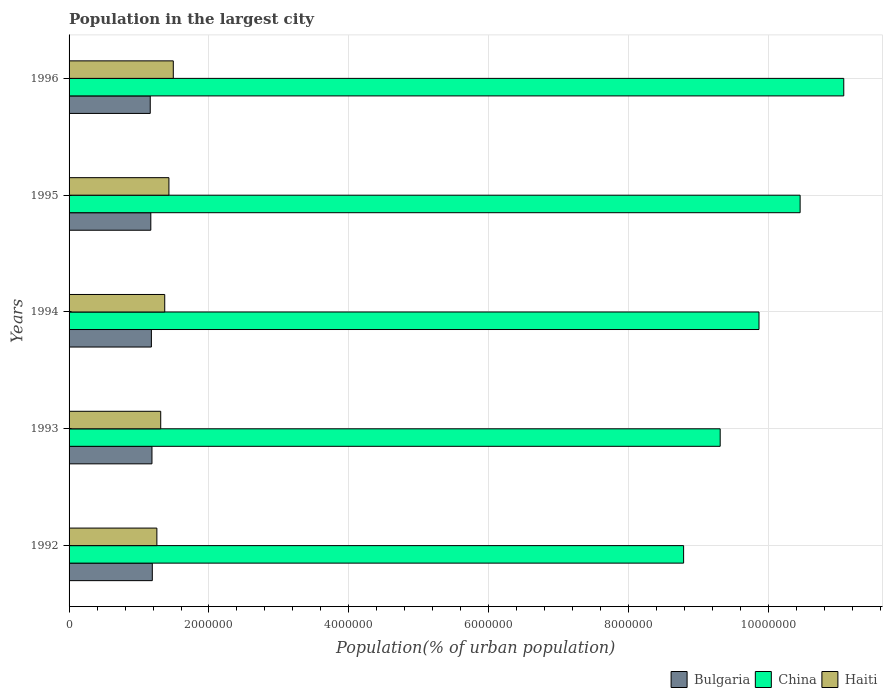How many different coloured bars are there?
Offer a very short reply. 3. How many groups of bars are there?
Give a very brief answer. 5. Are the number of bars on each tick of the Y-axis equal?
Keep it short and to the point. Yes. How many bars are there on the 3rd tick from the bottom?
Offer a very short reply. 3. In how many cases, is the number of bars for a given year not equal to the number of legend labels?
Ensure brevity in your answer.  0. What is the population in the largest city in China in 1992?
Offer a terse response. 8.78e+06. Across all years, what is the maximum population in the largest city in Bulgaria?
Your response must be concise. 1.19e+06. Across all years, what is the minimum population in the largest city in Bulgaria?
Give a very brief answer. 1.16e+06. In which year was the population in the largest city in Bulgaria maximum?
Offer a very short reply. 1992. What is the total population in the largest city in China in the graph?
Give a very brief answer. 4.95e+07. What is the difference between the population in the largest city in China in 1993 and that in 1994?
Offer a terse response. -5.55e+05. What is the difference between the population in the largest city in China in 1992 and the population in the largest city in Bulgaria in 1996?
Offer a very short reply. 7.62e+06. What is the average population in the largest city in China per year?
Offer a terse response. 9.90e+06. In the year 1993, what is the difference between the population in the largest city in China and population in the largest city in Haiti?
Keep it short and to the point. 8.00e+06. What is the ratio of the population in the largest city in Haiti in 1993 to that in 1994?
Give a very brief answer. 0.96. What is the difference between the highest and the second highest population in the largest city in China?
Your answer should be compact. 6.24e+05. What is the difference between the highest and the lowest population in the largest city in Bulgaria?
Offer a very short reply. 2.95e+04. What does the 2nd bar from the top in 1992 represents?
Offer a terse response. China. What does the 1st bar from the bottom in 1996 represents?
Your answer should be compact. Bulgaria. What is the difference between two consecutive major ticks on the X-axis?
Provide a short and direct response. 2.00e+06. Are the values on the major ticks of X-axis written in scientific E-notation?
Give a very brief answer. No. Does the graph contain grids?
Make the answer very short. Yes. Where does the legend appear in the graph?
Provide a succinct answer. Bottom right. How many legend labels are there?
Ensure brevity in your answer.  3. What is the title of the graph?
Give a very brief answer. Population in the largest city. Does "India" appear as one of the legend labels in the graph?
Your answer should be compact. No. What is the label or title of the X-axis?
Give a very brief answer. Population(% of urban population). What is the label or title of the Y-axis?
Provide a succinct answer. Years. What is the Population(% of urban population) in Bulgaria in 1992?
Offer a very short reply. 1.19e+06. What is the Population(% of urban population) in China in 1992?
Make the answer very short. 8.78e+06. What is the Population(% of urban population) of Haiti in 1992?
Provide a succinct answer. 1.26e+06. What is the Population(% of urban population) in Bulgaria in 1993?
Offer a terse response. 1.18e+06. What is the Population(% of urban population) in China in 1993?
Your response must be concise. 9.31e+06. What is the Population(% of urban population) in Haiti in 1993?
Provide a succinct answer. 1.31e+06. What is the Population(% of urban population) of Bulgaria in 1994?
Offer a terse response. 1.18e+06. What is the Population(% of urban population) of China in 1994?
Your response must be concise. 9.86e+06. What is the Population(% of urban population) in Haiti in 1994?
Your response must be concise. 1.37e+06. What is the Population(% of urban population) of Bulgaria in 1995?
Provide a short and direct response. 1.17e+06. What is the Population(% of urban population) of China in 1995?
Your answer should be very brief. 1.04e+07. What is the Population(% of urban population) in Haiti in 1995?
Offer a very short reply. 1.43e+06. What is the Population(% of urban population) in Bulgaria in 1996?
Your response must be concise. 1.16e+06. What is the Population(% of urban population) in China in 1996?
Your answer should be compact. 1.11e+07. What is the Population(% of urban population) of Haiti in 1996?
Give a very brief answer. 1.49e+06. Across all years, what is the maximum Population(% of urban population) of Bulgaria?
Your response must be concise. 1.19e+06. Across all years, what is the maximum Population(% of urban population) in China?
Make the answer very short. 1.11e+07. Across all years, what is the maximum Population(% of urban population) of Haiti?
Provide a short and direct response. 1.49e+06. Across all years, what is the minimum Population(% of urban population) of Bulgaria?
Your answer should be very brief. 1.16e+06. Across all years, what is the minimum Population(% of urban population) of China?
Make the answer very short. 8.78e+06. Across all years, what is the minimum Population(% of urban population) in Haiti?
Make the answer very short. 1.26e+06. What is the total Population(% of urban population) of Bulgaria in the graph?
Your response must be concise. 5.88e+06. What is the total Population(% of urban population) of China in the graph?
Make the answer very short. 4.95e+07. What is the total Population(% of urban population) in Haiti in the graph?
Keep it short and to the point. 6.85e+06. What is the difference between the Population(% of urban population) in Bulgaria in 1992 and that in 1993?
Provide a succinct answer. 4926. What is the difference between the Population(% of urban population) in China in 1992 and that in 1993?
Provide a short and direct response. -5.23e+05. What is the difference between the Population(% of urban population) of Haiti in 1992 and that in 1993?
Your answer should be very brief. -5.49e+04. What is the difference between the Population(% of urban population) of Bulgaria in 1992 and that in 1994?
Provide a short and direct response. 1.32e+04. What is the difference between the Population(% of urban population) in China in 1992 and that in 1994?
Your answer should be very brief. -1.08e+06. What is the difference between the Population(% of urban population) of Haiti in 1992 and that in 1994?
Make the answer very short. -1.12e+05. What is the difference between the Population(% of urban population) in Bulgaria in 1992 and that in 1995?
Provide a short and direct response. 2.14e+04. What is the difference between the Population(% of urban population) of China in 1992 and that in 1995?
Offer a terse response. -1.67e+06. What is the difference between the Population(% of urban population) of Haiti in 1992 and that in 1995?
Offer a terse response. -1.72e+05. What is the difference between the Population(% of urban population) in Bulgaria in 1992 and that in 1996?
Your answer should be very brief. 2.95e+04. What is the difference between the Population(% of urban population) of China in 1992 and that in 1996?
Keep it short and to the point. -2.29e+06. What is the difference between the Population(% of urban population) of Haiti in 1992 and that in 1996?
Provide a short and direct response. -2.35e+05. What is the difference between the Population(% of urban population) in Bulgaria in 1993 and that in 1994?
Offer a terse response. 8261. What is the difference between the Population(% of urban population) in China in 1993 and that in 1994?
Give a very brief answer. -5.55e+05. What is the difference between the Population(% of urban population) in Haiti in 1993 and that in 1994?
Offer a very short reply. -5.74e+04. What is the difference between the Population(% of urban population) of Bulgaria in 1993 and that in 1995?
Make the answer very short. 1.65e+04. What is the difference between the Population(% of urban population) of China in 1993 and that in 1995?
Make the answer very short. -1.14e+06. What is the difference between the Population(% of urban population) of Haiti in 1993 and that in 1995?
Provide a short and direct response. -1.17e+05. What is the difference between the Population(% of urban population) of Bulgaria in 1993 and that in 1996?
Offer a terse response. 2.46e+04. What is the difference between the Population(% of urban population) in China in 1993 and that in 1996?
Your answer should be compact. -1.77e+06. What is the difference between the Population(% of urban population) of Haiti in 1993 and that in 1996?
Give a very brief answer. -1.80e+05. What is the difference between the Population(% of urban population) of Bulgaria in 1994 and that in 1995?
Provide a short and direct response. 8203. What is the difference between the Population(% of urban population) of China in 1994 and that in 1995?
Ensure brevity in your answer.  -5.88e+05. What is the difference between the Population(% of urban population) of Haiti in 1994 and that in 1995?
Make the answer very short. -5.99e+04. What is the difference between the Population(% of urban population) in Bulgaria in 1994 and that in 1996?
Your response must be concise. 1.64e+04. What is the difference between the Population(% of urban population) of China in 1994 and that in 1996?
Give a very brief answer. -1.21e+06. What is the difference between the Population(% of urban population) in Haiti in 1994 and that in 1996?
Make the answer very short. -1.23e+05. What is the difference between the Population(% of urban population) in Bulgaria in 1995 and that in 1996?
Ensure brevity in your answer.  8158. What is the difference between the Population(% of urban population) in China in 1995 and that in 1996?
Keep it short and to the point. -6.24e+05. What is the difference between the Population(% of urban population) of Haiti in 1995 and that in 1996?
Your answer should be compact. -6.26e+04. What is the difference between the Population(% of urban population) in Bulgaria in 1992 and the Population(% of urban population) in China in 1993?
Offer a very short reply. -8.12e+06. What is the difference between the Population(% of urban population) in Bulgaria in 1992 and the Population(% of urban population) in Haiti in 1993?
Offer a terse response. -1.20e+05. What is the difference between the Population(% of urban population) in China in 1992 and the Population(% of urban population) in Haiti in 1993?
Offer a terse response. 7.47e+06. What is the difference between the Population(% of urban population) in Bulgaria in 1992 and the Population(% of urban population) in China in 1994?
Your answer should be very brief. -8.67e+06. What is the difference between the Population(% of urban population) in Bulgaria in 1992 and the Population(% of urban population) in Haiti in 1994?
Your answer should be compact. -1.78e+05. What is the difference between the Population(% of urban population) of China in 1992 and the Population(% of urban population) of Haiti in 1994?
Your answer should be compact. 7.42e+06. What is the difference between the Population(% of urban population) of Bulgaria in 1992 and the Population(% of urban population) of China in 1995?
Offer a terse response. -9.26e+06. What is the difference between the Population(% of urban population) in Bulgaria in 1992 and the Population(% of urban population) in Haiti in 1995?
Ensure brevity in your answer.  -2.37e+05. What is the difference between the Population(% of urban population) of China in 1992 and the Population(% of urban population) of Haiti in 1995?
Give a very brief answer. 7.36e+06. What is the difference between the Population(% of urban population) of Bulgaria in 1992 and the Population(% of urban population) of China in 1996?
Provide a succinct answer. -9.88e+06. What is the difference between the Population(% of urban population) in Bulgaria in 1992 and the Population(% of urban population) in Haiti in 1996?
Give a very brief answer. -3.00e+05. What is the difference between the Population(% of urban population) in China in 1992 and the Population(% of urban population) in Haiti in 1996?
Offer a terse response. 7.29e+06. What is the difference between the Population(% of urban population) in Bulgaria in 1993 and the Population(% of urban population) in China in 1994?
Your answer should be very brief. -8.68e+06. What is the difference between the Population(% of urban population) in Bulgaria in 1993 and the Population(% of urban population) in Haiti in 1994?
Make the answer very short. -1.82e+05. What is the difference between the Population(% of urban population) of China in 1993 and the Population(% of urban population) of Haiti in 1994?
Your answer should be very brief. 7.94e+06. What is the difference between the Population(% of urban population) in Bulgaria in 1993 and the Population(% of urban population) in China in 1995?
Offer a very short reply. -9.26e+06. What is the difference between the Population(% of urban population) in Bulgaria in 1993 and the Population(% of urban population) in Haiti in 1995?
Offer a terse response. -2.42e+05. What is the difference between the Population(% of urban population) of China in 1993 and the Population(% of urban population) of Haiti in 1995?
Give a very brief answer. 7.88e+06. What is the difference between the Population(% of urban population) in Bulgaria in 1993 and the Population(% of urban population) in China in 1996?
Offer a very short reply. -9.89e+06. What is the difference between the Population(% of urban population) of Bulgaria in 1993 and the Population(% of urban population) of Haiti in 1996?
Your answer should be very brief. -3.05e+05. What is the difference between the Population(% of urban population) in China in 1993 and the Population(% of urban population) in Haiti in 1996?
Keep it short and to the point. 7.82e+06. What is the difference between the Population(% of urban population) of Bulgaria in 1994 and the Population(% of urban population) of China in 1995?
Your response must be concise. -9.27e+06. What is the difference between the Population(% of urban population) of Bulgaria in 1994 and the Population(% of urban population) of Haiti in 1995?
Ensure brevity in your answer.  -2.51e+05. What is the difference between the Population(% of urban population) in China in 1994 and the Population(% of urban population) in Haiti in 1995?
Give a very brief answer. 8.43e+06. What is the difference between the Population(% of urban population) of Bulgaria in 1994 and the Population(% of urban population) of China in 1996?
Ensure brevity in your answer.  -9.90e+06. What is the difference between the Population(% of urban population) in Bulgaria in 1994 and the Population(% of urban population) in Haiti in 1996?
Your answer should be very brief. -3.13e+05. What is the difference between the Population(% of urban population) of China in 1994 and the Population(% of urban population) of Haiti in 1996?
Provide a short and direct response. 8.37e+06. What is the difference between the Population(% of urban population) in Bulgaria in 1995 and the Population(% of urban population) in China in 1996?
Ensure brevity in your answer.  -9.90e+06. What is the difference between the Population(% of urban population) of Bulgaria in 1995 and the Population(% of urban population) of Haiti in 1996?
Give a very brief answer. -3.21e+05. What is the difference between the Population(% of urban population) in China in 1995 and the Population(% of urban population) in Haiti in 1996?
Your answer should be compact. 8.96e+06. What is the average Population(% of urban population) of Bulgaria per year?
Your answer should be compact. 1.18e+06. What is the average Population(% of urban population) of China per year?
Give a very brief answer. 9.90e+06. What is the average Population(% of urban population) in Haiti per year?
Ensure brevity in your answer.  1.37e+06. In the year 1992, what is the difference between the Population(% of urban population) in Bulgaria and Population(% of urban population) in China?
Your answer should be compact. -7.59e+06. In the year 1992, what is the difference between the Population(% of urban population) in Bulgaria and Population(% of urban population) in Haiti?
Your answer should be very brief. -6.52e+04. In the year 1992, what is the difference between the Population(% of urban population) in China and Population(% of urban population) in Haiti?
Make the answer very short. 7.53e+06. In the year 1993, what is the difference between the Population(% of urban population) of Bulgaria and Population(% of urban population) of China?
Your response must be concise. -8.12e+06. In the year 1993, what is the difference between the Population(% of urban population) of Bulgaria and Population(% of urban population) of Haiti?
Offer a very short reply. -1.25e+05. In the year 1993, what is the difference between the Population(% of urban population) of China and Population(% of urban population) of Haiti?
Offer a terse response. 8.00e+06. In the year 1994, what is the difference between the Population(% of urban population) in Bulgaria and Population(% of urban population) in China?
Offer a very short reply. -8.69e+06. In the year 1994, what is the difference between the Population(% of urban population) in Bulgaria and Population(% of urban population) in Haiti?
Offer a very short reply. -1.91e+05. In the year 1994, what is the difference between the Population(% of urban population) in China and Population(% of urban population) in Haiti?
Provide a succinct answer. 8.49e+06. In the year 1995, what is the difference between the Population(% of urban population) in Bulgaria and Population(% of urban population) in China?
Make the answer very short. -9.28e+06. In the year 1995, what is the difference between the Population(% of urban population) of Bulgaria and Population(% of urban population) of Haiti?
Offer a terse response. -2.59e+05. In the year 1995, what is the difference between the Population(% of urban population) in China and Population(% of urban population) in Haiti?
Give a very brief answer. 9.02e+06. In the year 1996, what is the difference between the Population(% of urban population) in Bulgaria and Population(% of urban population) in China?
Offer a very short reply. -9.91e+06. In the year 1996, what is the difference between the Population(% of urban population) of Bulgaria and Population(% of urban population) of Haiti?
Give a very brief answer. -3.30e+05. In the year 1996, what is the difference between the Population(% of urban population) in China and Population(% of urban population) in Haiti?
Make the answer very short. 9.58e+06. What is the ratio of the Population(% of urban population) of Bulgaria in 1992 to that in 1993?
Make the answer very short. 1. What is the ratio of the Population(% of urban population) of China in 1992 to that in 1993?
Provide a succinct answer. 0.94. What is the ratio of the Population(% of urban population) of Haiti in 1992 to that in 1993?
Give a very brief answer. 0.96. What is the ratio of the Population(% of urban population) of Bulgaria in 1992 to that in 1994?
Provide a succinct answer. 1.01. What is the ratio of the Population(% of urban population) of China in 1992 to that in 1994?
Your answer should be very brief. 0.89. What is the ratio of the Population(% of urban population) of Haiti in 1992 to that in 1994?
Provide a short and direct response. 0.92. What is the ratio of the Population(% of urban population) in Bulgaria in 1992 to that in 1995?
Ensure brevity in your answer.  1.02. What is the ratio of the Population(% of urban population) in China in 1992 to that in 1995?
Offer a very short reply. 0.84. What is the ratio of the Population(% of urban population) in Haiti in 1992 to that in 1995?
Offer a terse response. 0.88. What is the ratio of the Population(% of urban population) of Bulgaria in 1992 to that in 1996?
Your answer should be very brief. 1.03. What is the ratio of the Population(% of urban population) of China in 1992 to that in 1996?
Provide a short and direct response. 0.79. What is the ratio of the Population(% of urban population) in Haiti in 1992 to that in 1996?
Provide a short and direct response. 0.84. What is the ratio of the Population(% of urban population) of China in 1993 to that in 1994?
Provide a short and direct response. 0.94. What is the ratio of the Population(% of urban population) in Haiti in 1993 to that in 1994?
Provide a short and direct response. 0.96. What is the ratio of the Population(% of urban population) in Bulgaria in 1993 to that in 1995?
Your answer should be compact. 1.01. What is the ratio of the Population(% of urban population) in China in 1993 to that in 1995?
Ensure brevity in your answer.  0.89. What is the ratio of the Population(% of urban population) of Haiti in 1993 to that in 1995?
Offer a very short reply. 0.92. What is the ratio of the Population(% of urban population) of Bulgaria in 1993 to that in 1996?
Offer a terse response. 1.02. What is the ratio of the Population(% of urban population) of China in 1993 to that in 1996?
Your answer should be compact. 0.84. What is the ratio of the Population(% of urban population) in Haiti in 1993 to that in 1996?
Provide a succinct answer. 0.88. What is the ratio of the Population(% of urban population) in China in 1994 to that in 1995?
Your answer should be compact. 0.94. What is the ratio of the Population(% of urban population) of Haiti in 1994 to that in 1995?
Give a very brief answer. 0.96. What is the ratio of the Population(% of urban population) of Bulgaria in 1994 to that in 1996?
Offer a terse response. 1.01. What is the ratio of the Population(% of urban population) in China in 1994 to that in 1996?
Offer a very short reply. 0.89. What is the ratio of the Population(% of urban population) of Haiti in 1994 to that in 1996?
Provide a succinct answer. 0.92. What is the ratio of the Population(% of urban population) of Bulgaria in 1995 to that in 1996?
Your answer should be compact. 1.01. What is the ratio of the Population(% of urban population) in China in 1995 to that in 1996?
Offer a terse response. 0.94. What is the ratio of the Population(% of urban population) in Haiti in 1995 to that in 1996?
Provide a short and direct response. 0.96. What is the difference between the highest and the second highest Population(% of urban population) of Bulgaria?
Ensure brevity in your answer.  4926. What is the difference between the highest and the second highest Population(% of urban population) of China?
Keep it short and to the point. 6.24e+05. What is the difference between the highest and the second highest Population(% of urban population) of Haiti?
Your answer should be very brief. 6.26e+04. What is the difference between the highest and the lowest Population(% of urban population) of Bulgaria?
Ensure brevity in your answer.  2.95e+04. What is the difference between the highest and the lowest Population(% of urban population) of China?
Offer a very short reply. 2.29e+06. What is the difference between the highest and the lowest Population(% of urban population) in Haiti?
Your response must be concise. 2.35e+05. 